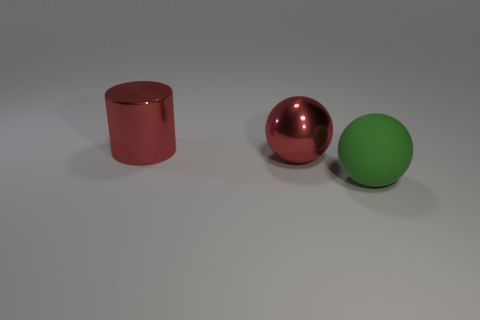Subtract all cyan spheres. Subtract all cyan cubes. How many spheres are left? 2 Subtract all green cubes. How many brown cylinders are left? 0 Add 2 tiny blues. How many big reds exist? 0 Subtract all large green matte balls. Subtract all green matte spheres. How many objects are left? 1 Add 1 large red metal spheres. How many large red metal spheres are left? 2 Add 3 cyan metallic cylinders. How many cyan metallic cylinders exist? 3 Add 1 matte objects. How many objects exist? 4 Subtract all red spheres. How many spheres are left? 1 Subtract 0 blue cylinders. How many objects are left? 3 Subtract all spheres. How many objects are left? 1 